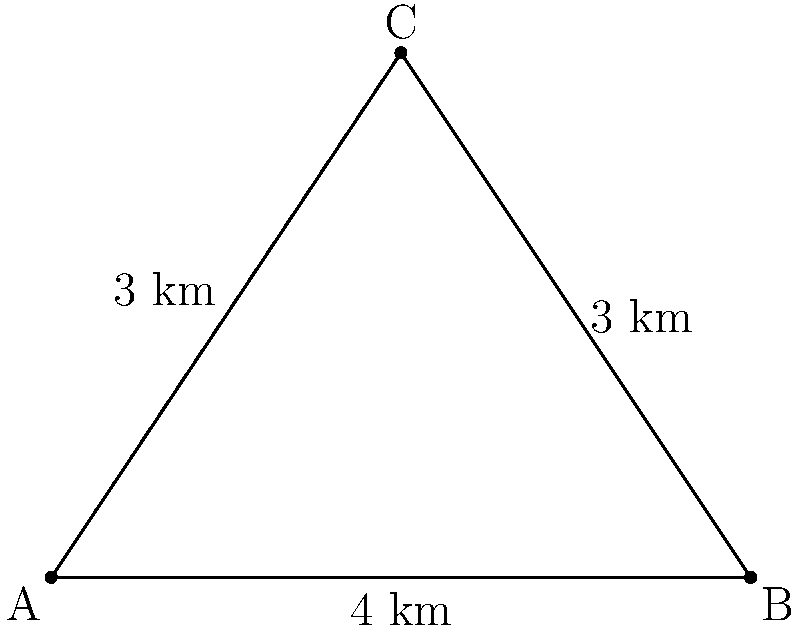In planning an efficient public transportation route in Kerala, you're considering connecting three areas: A, B, and C. The distances between these points form a triangle with sides of 3 km, 3 km, and 4 km. What is the shortest total distance of paved road needed to connect all three points, and which route configuration achieves this? To determine the shortest total distance of paved road needed to connect all three points, we need to consider the following steps:

1. First, let's identify the given information:
   - We have a triangle with sides 3 km, 3 km, and 4 km.
   - We need to connect all three points.

2. There are two possible configurations to connect these points:
   a) Using all three sides of the triangle
   b) Using two sides of the triangle (the two shorter sides)

3. Calculate the total distance for each configuration:
   a) All three sides: 3 km + 3 km + 4 km = 10 km
   b) Two shorter sides: 3 km + 3 km = 6 km

4. Compare the two configurations:
   Configuration (b) with 6 km is shorter than configuration (a) with 10 km.

5. The shortest configuration is achieved by connecting point C to both A and B directly, forming a "V" shape rather than a complete triangle.

6. This configuration is known as the "Steiner tree" for three points, where the optimal solution is always to connect the two shorter sides when one side is longer than the other two.

Therefore, the shortest total distance of paved road needed is 6 km, achieved by connecting point C to both A and B directly.
Answer: 6 km, connecting point C to both A and B directly. 